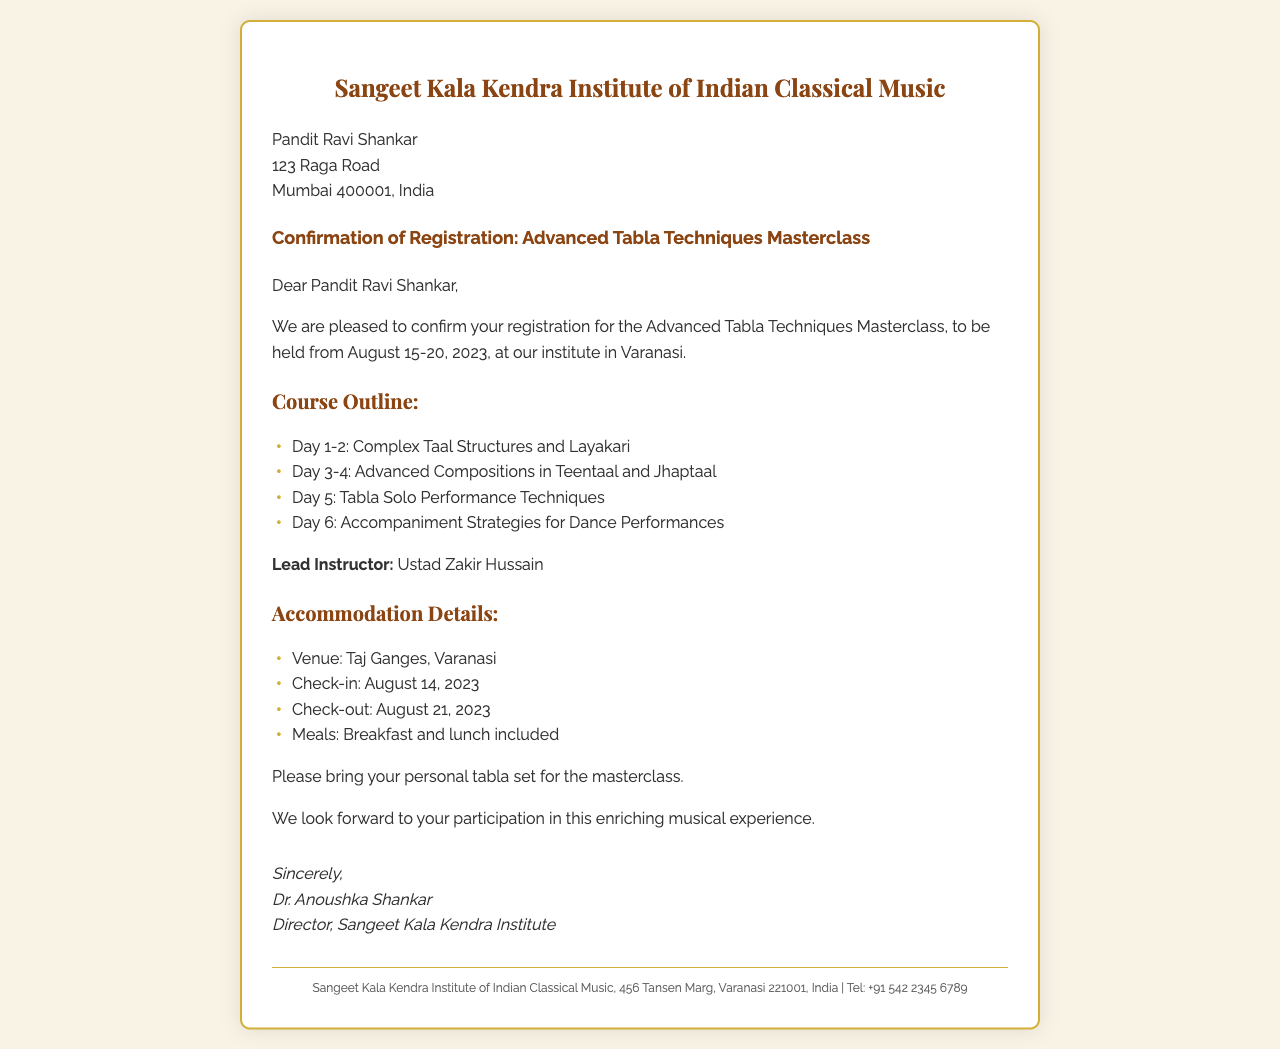what are the dates of the masterclass? The masterclass is scheduled to be held from August 15-20, 2023.
Answer: August 15-20, 2023 who is the lead instructor? The document states that the lead instructor for the masterclass is Ustad Zakir Hussain.
Answer: Ustad Zakir Hussain what is the venue for accommodation? The accommodation is provided at the Taj Ganges in Varanasi.
Answer: Taj Ganges, Varanasi how many days does the masterclass run? The masterclass runs for a total of six days from August 15 to August 20, 2023.
Answer: Six days which meals are included with the accommodation? The document mentions that breakfast and lunch are included in the accommodation details.
Answer: Breakfast and lunch what should participants bring to the masterclass? The document requests participants to bring their personal tabla set for the masterclass.
Answer: Personal tabla set what are the check-in and check-out dates for accommodation? The check-in date is August 14, 2023, and the check-out date is August 21, 2023.
Answer: August 14, 2023, and August 21, 2023 how many topics are covered in the course outline? There are four distinct topics listed in the course outline over the six days of the masterclass.
Answer: Four topics 